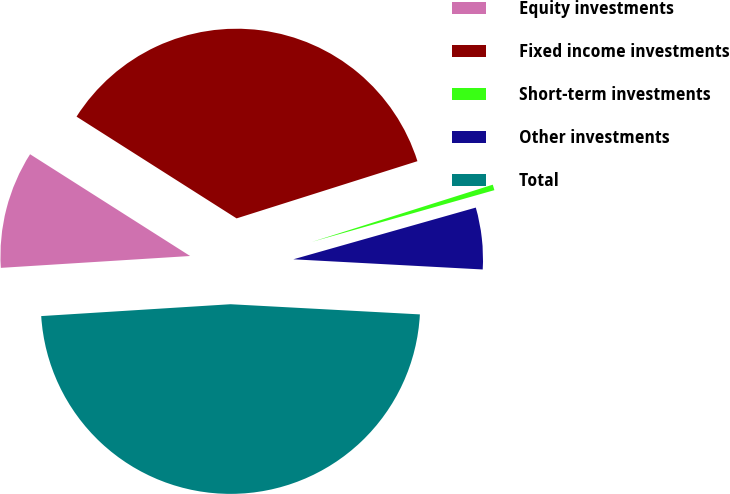Convert chart. <chart><loc_0><loc_0><loc_500><loc_500><pie_chart><fcel>Equity investments<fcel>Fixed income investments<fcel>Short-term investments<fcel>Other investments<fcel>Total<nl><fcel>10.01%<fcel>36.11%<fcel>0.48%<fcel>5.25%<fcel>48.15%<nl></chart> 